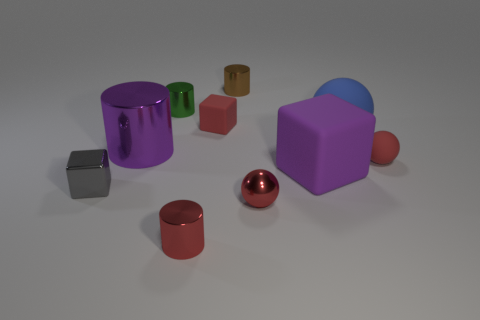Is the material of the small brown cylinder the same as the small ball behind the purple rubber block?
Provide a succinct answer. No. Are there more green shiny cylinders than large gray objects?
Your response must be concise. Yes. How many blocks are big purple objects or purple rubber objects?
Provide a succinct answer. 1. What color is the tiny shiny ball?
Provide a short and direct response. Red. Is the size of the purple thing that is right of the purple shiny object the same as the red metal object that is left of the tiny brown object?
Make the answer very short. No. Are there fewer red metallic things than tiny red cylinders?
Offer a terse response. No. What number of shiny cylinders are to the left of the small red cylinder?
Offer a terse response. 2. What is the material of the small gray cube?
Your answer should be very brief. Metal. Does the small metallic sphere have the same color as the small rubber cube?
Offer a terse response. Yes. Are there fewer purple metal cylinders that are behind the large blue matte sphere than matte cylinders?
Provide a short and direct response. No. 